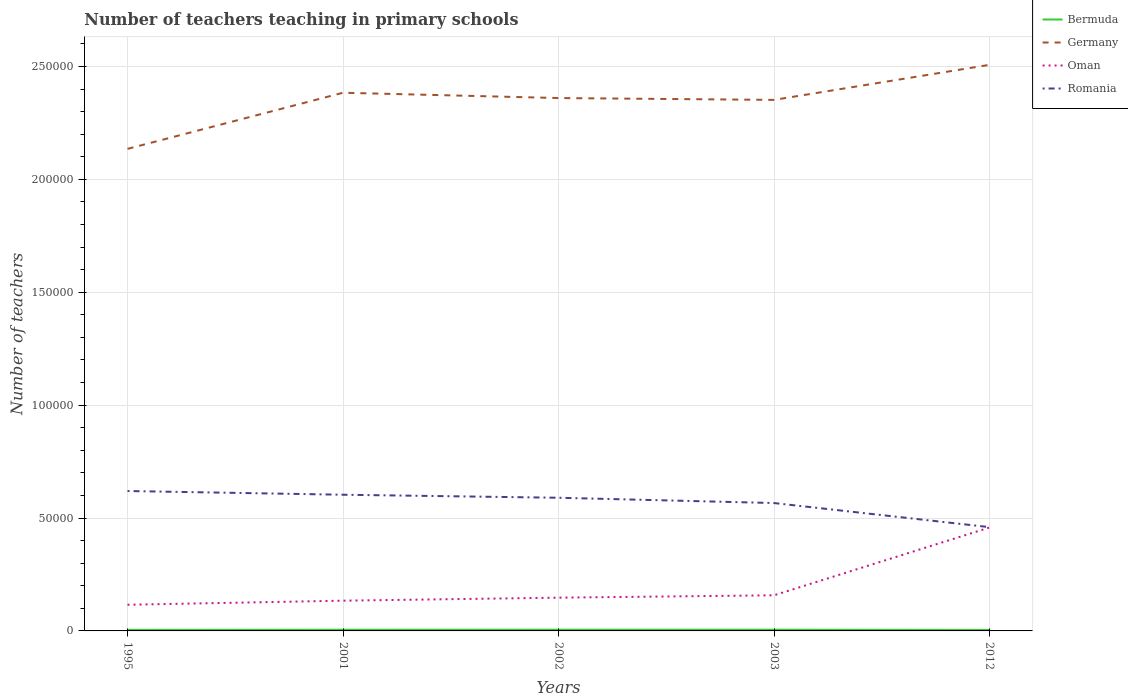How many different coloured lines are there?
Keep it short and to the point. 4. Does the line corresponding to Bermuda intersect with the line corresponding to Oman?
Provide a succinct answer. No. Across all years, what is the maximum number of teachers teaching in primary schools in Romania?
Offer a very short reply. 4.60e+04. In which year was the number of teachers teaching in primary schools in Romania maximum?
Your answer should be very brief. 2012. What is the total number of teachers teaching in primary schools in Germany in the graph?
Give a very brief answer. -2.49e+04. What is the difference between the highest and the second highest number of teachers teaching in primary schools in Germany?
Your response must be concise. 3.72e+04. What is the difference between the highest and the lowest number of teachers teaching in primary schools in Bermuda?
Your answer should be very brief. 3. Is the number of teachers teaching in primary schools in Oman strictly greater than the number of teachers teaching in primary schools in Romania over the years?
Ensure brevity in your answer.  Yes. What is the difference between two consecutive major ticks on the Y-axis?
Your response must be concise. 5.00e+04. Does the graph contain any zero values?
Ensure brevity in your answer.  No. Where does the legend appear in the graph?
Give a very brief answer. Top right. How many legend labels are there?
Your answer should be compact. 4. How are the legend labels stacked?
Offer a terse response. Vertical. What is the title of the graph?
Provide a short and direct response. Number of teachers teaching in primary schools. Does "Estonia" appear as one of the legend labels in the graph?
Make the answer very short. No. What is the label or title of the X-axis?
Provide a short and direct response. Years. What is the label or title of the Y-axis?
Offer a very short reply. Number of teachers. What is the Number of teachers in Bermuda in 1995?
Provide a short and direct response. 463. What is the Number of teachers in Germany in 1995?
Provide a succinct answer. 2.13e+05. What is the Number of teachers of Oman in 1995?
Offer a terse response. 1.16e+04. What is the Number of teachers of Romania in 1995?
Provide a short and direct response. 6.20e+04. What is the Number of teachers of Bermuda in 2001?
Provide a succinct answer. 536. What is the Number of teachers of Germany in 2001?
Your answer should be compact. 2.38e+05. What is the Number of teachers of Oman in 2001?
Ensure brevity in your answer.  1.34e+04. What is the Number of teachers of Romania in 2001?
Your answer should be compact. 6.03e+04. What is the Number of teachers in Bermuda in 2002?
Your answer should be very brief. 548. What is the Number of teachers in Germany in 2002?
Keep it short and to the point. 2.36e+05. What is the Number of teachers in Oman in 2002?
Provide a succinct answer. 1.47e+04. What is the Number of teachers in Romania in 2002?
Give a very brief answer. 5.90e+04. What is the Number of teachers in Bermuda in 2003?
Provide a short and direct response. 548. What is the Number of teachers of Germany in 2003?
Your response must be concise. 2.35e+05. What is the Number of teachers in Oman in 2003?
Offer a very short reply. 1.58e+04. What is the Number of teachers in Romania in 2003?
Your answer should be very brief. 5.66e+04. What is the Number of teachers of Bermuda in 2012?
Make the answer very short. 429. What is the Number of teachers of Germany in 2012?
Keep it short and to the point. 2.51e+05. What is the Number of teachers of Oman in 2012?
Provide a short and direct response. 4.58e+04. What is the Number of teachers of Romania in 2012?
Your answer should be very brief. 4.60e+04. Across all years, what is the maximum Number of teachers of Bermuda?
Make the answer very short. 548. Across all years, what is the maximum Number of teachers of Germany?
Offer a terse response. 2.51e+05. Across all years, what is the maximum Number of teachers of Oman?
Your answer should be compact. 4.58e+04. Across all years, what is the maximum Number of teachers in Romania?
Offer a terse response. 6.20e+04. Across all years, what is the minimum Number of teachers in Bermuda?
Offer a very short reply. 429. Across all years, what is the minimum Number of teachers in Germany?
Offer a terse response. 2.13e+05. Across all years, what is the minimum Number of teachers of Oman?
Make the answer very short. 1.16e+04. Across all years, what is the minimum Number of teachers in Romania?
Keep it short and to the point. 4.60e+04. What is the total Number of teachers in Bermuda in the graph?
Keep it short and to the point. 2524. What is the total Number of teachers in Germany in the graph?
Give a very brief answer. 1.17e+06. What is the total Number of teachers in Oman in the graph?
Keep it short and to the point. 1.01e+05. What is the total Number of teachers in Romania in the graph?
Offer a terse response. 2.84e+05. What is the difference between the Number of teachers of Bermuda in 1995 and that in 2001?
Ensure brevity in your answer.  -73. What is the difference between the Number of teachers of Germany in 1995 and that in 2001?
Keep it short and to the point. -2.49e+04. What is the difference between the Number of teachers of Oman in 1995 and that in 2001?
Ensure brevity in your answer.  -1808. What is the difference between the Number of teachers of Romania in 1995 and that in 2001?
Offer a very short reply. 1648. What is the difference between the Number of teachers of Bermuda in 1995 and that in 2002?
Provide a short and direct response. -85. What is the difference between the Number of teachers in Germany in 1995 and that in 2002?
Your response must be concise. -2.25e+04. What is the difference between the Number of teachers in Oman in 1995 and that in 2002?
Make the answer very short. -3142. What is the difference between the Number of teachers of Romania in 1995 and that in 2002?
Offer a very short reply. 2982. What is the difference between the Number of teachers in Bermuda in 1995 and that in 2003?
Give a very brief answer. -85. What is the difference between the Number of teachers of Germany in 1995 and that in 2003?
Your answer should be very brief. -2.17e+04. What is the difference between the Number of teachers in Oman in 1995 and that in 2003?
Give a very brief answer. -4189. What is the difference between the Number of teachers in Romania in 1995 and that in 2003?
Make the answer very short. 5325. What is the difference between the Number of teachers in Bermuda in 1995 and that in 2012?
Provide a short and direct response. 34. What is the difference between the Number of teachers in Germany in 1995 and that in 2012?
Provide a short and direct response. -3.72e+04. What is the difference between the Number of teachers of Oman in 1995 and that in 2012?
Provide a short and direct response. -3.42e+04. What is the difference between the Number of teachers of Romania in 1995 and that in 2012?
Give a very brief answer. 1.60e+04. What is the difference between the Number of teachers of Germany in 2001 and that in 2002?
Your answer should be compact. 2352. What is the difference between the Number of teachers of Oman in 2001 and that in 2002?
Your answer should be compact. -1334. What is the difference between the Number of teachers of Romania in 2001 and that in 2002?
Give a very brief answer. 1334. What is the difference between the Number of teachers in Bermuda in 2001 and that in 2003?
Offer a terse response. -12. What is the difference between the Number of teachers in Germany in 2001 and that in 2003?
Your answer should be compact. 3166. What is the difference between the Number of teachers in Oman in 2001 and that in 2003?
Keep it short and to the point. -2381. What is the difference between the Number of teachers in Romania in 2001 and that in 2003?
Ensure brevity in your answer.  3677. What is the difference between the Number of teachers of Bermuda in 2001 and that in 2012?
Provide a succinct answer. 107. What is the difference between the Number of teachers of Germany in 2001 and that in 2012?
Offer a terse response. -1.24e+04. What is the difference between the Number of teachers in Oman in 2001 and that in 2012?
Your answer should be very brief. -3.24e+04. What is the difference between the Number of teachers in Romania in 2001 and that in 2012?
Provide a succinct answer. 1.44e+04. What is the difference between the Number of teachers of Bermuda in 2002 and that in 2003?
Make the answer very short. 0. What is the difference between the Number of teachers of Germany in 2002 and that in 2003?
Make the answer very short. 814. What is the difference between the Number of teachers of Oman in 2002 and that in 2003?
Offer a terse response. -1047. What is the difference between the Number of teachers of Romania in 2002 and that in 2003?
Ensure brevity in your answer.  2343. What is the difference between the Number of teachers in Bermuda in 2002 and that in 2012?
Make the answer very short. 119. What is the difference between the Number of teachers in Germany in 2002 and that in 2012?
Keep it short and to the point. -1.47e+04. What is the difference between the Number of teachers of Oman in 2002 and that in 2012?
Your response must be concise. -3.11e+04. What is the difference between the Number of teachers in Romania in 2002 and that in 2012?
Your answer should be compact. 1.30e+04. What is the difference between the Number of teachers of Bermuda in 2003 and that in 2012?
Give a very brief answer. 119. What is the difference between the Number of teachers of Germany in 2003 and that in 2012?
Provide a succinct answer. -1.55e+04. What is the difference between the Number of teachers of Oman in 2003 and that in 2012?
Your response must be concise. -3.00e+04. What is the difference between the Number of teachers in Romania in 2003 and that in 2012?
Provide a short and direct response. 1.07e+04. What is the difference between the Number of teachers of Bermuda in 1995 and the Number of teachers of Germany in 2001?
Your answer should be compact. -2.38e+05. What is the difference between the Number of teachers of Bermuda in 1995 and the Number of teachers of Oman in 2001?
Provide a short and direct response. -1.29e+04. What is the difference between the Number of teachers in Bermuda in 1995 and the Number of teachers in Romania in 2001?
Provide a succinct answer. -5.98e+04. What is the difference between the Number of teachers of Germany in 1995 and the Number of teachers of Oman in 2001?
Your answer should be compact. 2.00e+05. What is the difference between the Number of teachers of Germany in 1995 and the Number of teachers of Romania in 2001?
Give a very brief answer. 1.53e+05. What is the difference between the Number of teachers of Oman in 1995 and the Number of teachers of Romania in 2001?
Make the answer very short. -4.87e+04. What is the difference between the Number of teachers in Bermuda in 1995 and the Number of teachers in Germany in 2002?
Keep it short and to the point. -2.36e+05. What is the difference between the Number of teachers of Bermuda in 1995 and the Number of teachers of Oman in 2002?
Ensure brevity in your answer.  -1.43e+04. What is the difference between the Number of teachers in Bermuda in 1995 and the Number of teachers in Romania in 2002?
Offer a terse response. -5.85e+04. What is the difference between the Number of teachers of Germany in 1995 and the Number of teachers of Oman in 2002?
Your answer should be compact. 1.99e+05. What is the difference between the Number of teachers in Germany in 1995 and the Number of teachers in Romania in 2002?
Give a very brief answer. 1.55e+05. What is the difference between the Number of teachers in Oman in 1995 and the Number of teachers in Romania in 2002?
Offer a terse response. -4.74e+04. What is the difference between the Number of teachers in Bermuda in 1995 and the Number of teachers in Germany in 2003?
Your answer should be very brief. -2.35e+05. What is the difference between the Number of teachers of Bermuda in 1995 and the Number of teachers of Oman in 2003?
Your answer should be compact. -1.53e+04. What is the difference between the Number of teachers of Bermuda in 1995 and the Number of teachers of Romania in 2003?
Provide a succinct answer. -5.62e+04. What is the difference between the Number of teachers of Germany in 1995 and the Number of teachers of Oman in 2003?
Ensure brevity in your answer.  1.98e+05. What is the difference between the Number of teachers in Germany in 1995 and the Number of teachers in Romania in 2003?
Offer a very short reply. 1.57e+05. What is the difference between the Number of teachers of Oman in 1995 and the Number of teachers of Romania in 2003?
Offer a terse response. -4.50e+04. What is the difference between the Number of teachers in Bermuda in 1995 and the Number of teachers in Germany in 2012?
Make the answer very short. -2.50e+05. What is the difference between the Number of teachers in Bermuda in 1995 and the Number of teachers in Oman in 2012?
Ensure brevity in your answer.  -4.53e+04. What is the difference between the Number of teachers in Bermuda in 1995 and the Number of teachers in Romania in 2012?
Offer a very short reply. -4.55e+04. What is the difference between the Number of teachers of Germany in 1995 and the Number of teachers of Oman in 2012?
Keep it short and to the point. 1.68e+05. What is the difference between the Number of teachers of Germany in 1995 and the Number of teachers of Romania in 2012?
Your answer should be very brief. 1.68e+05. What is the difference between the Number of teachers of Oman in 1995 and the Number of teachers of Romania in 2012?
Ensure brevity in your answer.  -3.44e+04. What is the difference between the Number of teachers in Bermuda in 2001 and the Number of teachers in Germany in 2002?
Provide a short and direct response. -2.35e+05. What is the difference between the Number of teachers of Bermuda in 2001 and the Number of teachers of Oman in 2002?
Your answer should be compact. -1.42e+04. What is the difference between the Number of teachers of Bermuda in 2001 and the Number of teachers of Romania in 2002?
Keep it short and to the point. -5.84e+04. What is the difference between the Number of teachers of Germany in 2001 and the Number of teachers of Oman in 2002?
Keep it short and to the point. 2.24e+05. What is the difference between the Number of teachers of Germany in 2001 and the Number of teachers of Romania in 2002?
Your response must be concise. 1.79e+05. What is the difference between the Number of teachers of Oman in 2001 and the Number of teachers of Romania in 2002?
Keep it short and to the point. -4.56e+04. What is the difference between the Number of teachers of Bermuda in 2001 and the Number of teachers of Germany in 2003?
Your answer should be very brief. -2.35e+05. What is the difference between the Number of teachers of Bermuda in 2001 and the Number of teachers of Oman in 2003?
Your answer should be compact. -1.52e+04. What is the difference between the Number of teachers of Bermuda in 2001 and the Number of teachers of Romania in 2003?
Your answer should be very brief. -5.61e+04. What is the difference between the Number of teachers of Germany in 2001 and the Number of teachers of Oman in 2003?
Your response must be concise. 2.23e+05. What is the difference between the Number of teachers in Germany in 2001 and the Number of teachers in Romania in 2003?
Provide a succinct answer. 1.82e+05. What is the difference between the Number of teachers in Oman in 2001 and the Number of teachers in Romania in 2003?
Your answer should be compact. -4.32e+04. What is the difference between the Number of teachers in Bermuda in 2001 and the Number of teachers in Germany in 2012?
Make the answer very short. -2.50e+05. What is the difference between the Number of teachers in Bermuda in 2001 and the Number of teachers in Oman in 2012?
Offer a very short reply. -4.53e+04. What is the difference between the Number of teachers in Bermuda in 2001 and the Number of teachers in Romania in 2012?
Your answer should be very brief. -4.54e+04. What is the difference between the Number of teachers in Germany in 2001 and the Number of teachers in Oman in 2012?
Make the answer very short. 1.93e+05. What is the difference between the Number of teachers of Germany in 2001 and the Number of teachers of Romania in 2012?
Ensure brevity in your answer.  1.92e+05. What is the difference between the Number of teachers of Oman in 2001 and the Number of teachers of Romania in 2012?
Your answer should be compact. -3.26e+04. What is the difference between the Number of teachers of Bermuda in 2002 and the Number of teachers of Germany in 2003?
Offer a very short reply. -2.35e+05. What is the difference between the Number of teachers of Bermuda in 2002 and the Number of teachers of Oman in 2003?
Keep it short and to the point. -1.52e+04. What is the difference between the Number of teachers of Bermuda in 2002 and the Number of teachers of Romania in 2003?
Provide a succinct answer. -5.61e+04. What is the difference between the Number of teachers in Germany in 2002 and the Number of teachers in Oman in 2003?
Offer a very short reply. 2.20e+05. What is the difference between the Number of teachers in Germany in 2002 and the Number of teachers in Romania in 2003?
Make the answer very short. 1.79e+05. What is the difference between the Number of teachers of Oman in 2002 and the Number of teachers of Romania in 2003?
Ensure brevity in your answer.  -4.19e+04. What is the difference between the Number of teachers of Bermuda in 2002 and the Number of teachers of Germany in 2012?
Keep it short and to the point. -2.50e+05. What is the difference between the Number of teachers in Bermuda in 2002 and the Number of teachers in Oman in 2012?
Your answer should be very brief. -4.52e+04. What is the difference between the Number of teachers of Bermuda in 2002 and the Number of teachers of Romania in 2012?
Offer a very short reply. -4.54e+04. What is the difference between the Number of teachers in Germany in 2002 and the Number of teachers in Oman in 2012?
Keep it short and to the point. 1.90e+05. What is the difference between the Number of teachers in Germany in 2002 and the Number of teachers in Romania in 2012?
Provide a succinct answer. 1.90e+05. What is the difference between the Number of teachers in Oman in 2002 and the Number of teachers in Romania in 2012?
Provide a succinct answer. -3.12e+04. What is the difference between the Number of teachers in Bermuda in 2003 and the Number of teachers in Germany in 2012?
Provide a succinct answer. -2.50e+05. What is the difference between the Number of teachers of Bermuda in 2003 and the Number of teachers of Oman in 2012?
Keep it short and to the point. -4.52e+04. What is the difference between the Number of teachers of Bermuda in 2003 and the Number of teachers of Romania in 2012?
Provide a succinct answer. -4.54e+04. What is the difference between the Number of teachers of Germany in 2003 and the Number of teachers of Oman in 2012?
Provide a succinct answer. 1.89e+05. What is the difference between the Number of teachers of Germany in 2003 and the Number of teachers of Romania in 2012?
Your answer should be compact. 1.89e+05. What is the difference between the Number of teachers of Oman in 2003 and the Number of teachers of Romania in 2012?
Give a very brief answer. -3.02e+04. What is the average Number of teachers in Bermuda per year?
Ensure brevity in your answer.  504.8. What is the average Number of teachers in Germany per year?
Offer a very short reply. 2.35e+05. What is the average Number of teachers of Oman per year?
Offer a very short reply. 2.03e+04. What is the average Number of teachers in Romania per year?
Provide a succinct answer. 5.68e+04. In the year 1995, what is the difference between the Number of teachers of Bermuda and Number of teachers of Germany?
Provide a succinct answer. -2.13e+05. In the year 1995, what is the difference between the Number of teachers in Bermuda and Number of teachers in Oman?
Ensure brevity in your answer.  -1.11e+04. In the year 1995, what is the difference between the Number of teachers of Bermuda and Number of teachers of Romania?
Ensure brevity in your answer.  -6.15e+04. In the year 1995, what is the difference between the Number of teachers in Germany and Number of teachers in Oman?
Offer a terse response. 2.02e+05. In the year 1995, what is the difference between the Number of teachers in Germany and Number of teachers in Romania?
Keep it short and to the point. 1.52e+05. In the year 1995, what is the difference between the Number of teachers in Oman and Number of teachers in Romania?
Provide a succinct answer. -5.04e+04. In the year 2001, what is the difference between the Number of teachers in Bermuda and Number of teachers in Germany?
Offer a terse response. -2.38e+05. In the year 2001, what is the difference between the Number of teachers in Bermuda and Number of teachers in Oman?
Offer a very short reply. -1.29e+04. In the year 2001, what is the difference between the Number of teachers of Bermuda and Number of teachers of Romania?
Give a very brief answer. -5.98e+04. In the year 2001, what is the difference between the Number of teachers of Germany and Number of teachers of Oman?
Ensure brevity in your answer.  2.25e+05. In the year 2001, what is the difference between the Number of teachers in Germany and Number of teachers in Romania?
Keep it short and to the point. 1.78e+05. In the year 2001, what is the difference between the Number of teachers of Oman and Number of teachers of Romania?
Offer a terse response. -4.69e+04. In the year 2002, what is the difference between the Number of teachers in Bermuda and Number of teachers in Germany?
Provide a succinct answer. -2.35e+05. In the year 2002, what is the difference between the Number of teachers in Bermuda and Number of teachers in Oman?
Provide a short and direct response. -1.42e+04. In the year 2002, what is the difference between the Number of teachers of Bermuda and Number of teachers of Romania?
Make the answer very short. -5.84e+04. In the year 2002, what is the difference between the Number of teachers in Germany and Number of teachers in Oman?
Make the answer very short. 2.21e+05. In the year 2002, what is the difference between the Number of teachers of Germany and Number of teachers of Romania?
Give a very brief answer. 1.77e+05. In the year 2002, what is the difference between the Number of teachers of Oman and Number of teachers of Romania?
Your answer should be very brief. -4.42e+04. In the year 2003, what is the difference between the Number of teachers of Bermuda and Number of teachers of Germany?
Your answer should be compact. -2.35e+05. In the year 2003, what is the difference between the Number of teachers of Bermuda and Number of teachers of Oman?
Provide a short and direct response. -1.52e+04. In the year 2003, what is the difference between the Number of teachers in Bermuda and Number of teachers in Romania?
Make the answer very short. -5.61e+04. In the year 2003, what is the difference between the Number of teachers in Germany and Number of teachers in Oman?
Offer a very short reply. 2.19e+05. In the year 2003, what is the difference between the Number of teachers of Germany and Number of teachers of Romania?
Provide a succinct answer. 1.79e+05. In the year 2003, what is the difference between the Number of teachers in Oman and Number of teachers in Romania?
Keep it short and to the point. -4.09e+04. In the year 2012, what is the difference between the Number of teachers of Bermuda and Number of teachers of Germany?
Offer a terse response. -2.50e+05. In the year 2012, what is the difference between the Number of teachers in Bermuda and Number of teachers in Oman?
Give a very brief answer. -4.54e+04. In the year 2012, what is the difference between the Number of teachers of Bermuda and Number of teachers of Romania?
Give a very brief answer. -4.55e+04. In the year 2012, what is the difference between the Number of teachers of Germany and Number of teachers of Oman?
Your answer should be compact. 2.05e+05. In the year 2012, what is the difference between the Number of teachers of Germany and Number of teachers of Romania?
Your answer should be compact. 2.05e+05. In the year 2012, what is the difference between the Number of teachers in Oman and Number of teachers in Romania?
Make the answer very short. -167. What is the ratio of the Number of teachers in Bermuda in 1995 to that in 2001?
Provide a short and direct response. 0.86. What is the ratio of the Number of teachers in Germany in 1995 to that in 2001?
Your answer should be compact. 0.9. What is the ratio of the Number of teachers of Oman in 1995 to that in 2001?
Ensure brevity in your answer.  0.86. What is the ratio of the Number of teachers in Romania in 1995 to that in 2001?
Provide a short and direct response. 1.03. What is the ratio of the Number of teachers of Bermuda in 1995 to that in 2002?
Give a very brief answer. 0.84. What is the ratio of the Number of teachers in Germany in 1995 to that in 2002?
Your response must be concise. 0.9. What is the ratio of the Number of teachers of Oman in 1995 to that in 2002?
Keep it short and to the point. 0.79. What is the ratio of the Number of teachers in Romania in 1995 to that in 2002?
Offer a terse response. 1.05. What is the ratio of the Number of teachers of Bermuda in 1995 to that in 2003?
Provide a succinct answer. 0.84. What is the ratio of the Number of teachers in Germany in 1995 to that in 2003?
Offer a terse response. 0.91. What is the ratio of the Number of teachers of Oman in 1995 to that in 2003?
Keep it short and to the point. 0.73. What is the ratio of the Number of teachers of Romania in 1995 to that in 2003?
Make the answer very short. 1.09. What is the ratio of the Number of teachers of Bermuda in 1995 to that in 2012?
Provide a short and direct response. 1.08. What is the ratio of the Number of teachers of Germany in 1995 to that in 2012?
Give a very brief answer. 0.85. What is the ratio of the Number of teachers in Oman in 1995 to that in 2012?
Offer a very short reply. 0.25. What is the ratio of the Number of teachers in Romania in 1995 to that in 2012?
Ensure brevity in your answer.  1.35. What is the ratio of the Number of teachers of Bermuda in 2001 to that in 2002?
Give a very brief answer. 0.98. What is the ratio of the Number of teachers in Germany in 2001 to that in 2002?
Your answer should be compact. 1.01. What is the ratio of the Number of teachers in Oman in 2001 to that in 2002?
Offer a terse response. 0.91. What is the ratio of the Number of teachers in Romania in 2001 to that in 2002?
Ensure brevity in your answer.  1.02. What is the ratio of the Number of teachers in Bermuda in 2001 to that in 2003?
Offer a very short reply. 0.98. What is the ratio of the Number of teachers of Germany in 2001 to that in 2003?
Ensure brevity in your answer.  1.01. What is the ratio of the Number of teachers of Oman in 2001 to that in 2003?
Your answer should be very brief. 0.85. What is the ratio of the Number of teachers of Romania in 2001 to that in 2003?
Your answer should be very brief. 1.06. What is the ratio of the Number of teachers in Bermuda in 2001 to that in 2012?
Ensure brevity in your answer.  1.25. What is the ratio of the Number of teachers of Germany in 2001 to that in 2012?
Provide a short and direct response. 0.95. What is the ratio of the Number of teachers in Oman in 2001 to that in 2012?
Keep it short and to the point. 0.29. What is the ratio of the Number of teachers of Romania in 2001 to that in 2012?
Your response must be concise. 1.31. What is the ratio of the Number of teachers in Oman in 2002 to that in 2003?
Give a very brief answer. 0.93. What is the ratio of the Number of teachers of Romania in 2002 to that in 2003?
Offer a very short reply. 1.04. What is the ratio of the Number of teachers in Bermuda in 2002 to that in 2012?
Your answer should be very brief. 1.28. What is the ratio of the Number of teachers of Germany in 2002 to that in 2012?
Your answer should be compact. 0.94. What is the ratio of the Number of teachers of Oman in 2002 to that in 2012?
Offer a terse response. 0.32. What is the ratio of the Number of teachers in Romania in 2002 to that in 2012?
Your answer should be very brief. 1.28. What is the ratio of the Number of teachers in Bermuda in 2003 to that in 2012?
Provide a succinct answer. 1.28. What is the ratio of the Number of teachers of Germany in 2003 to that in 2012?
Give a very brief answer. 0.94. What is the ratio of the Number of teachers of Oman in 2003 to that in 2012?
Keep it short and to the point. 0.34. What is the ratio of the Number of teachers in Romania in 2003 to that in 2012?
Offer a terse response. 1.23. What is the difference between the highest and the second highest Number of teachers of Germany?
Your answer should be very brief. 1.24e+04. What is the difference between the highest and the second highest Number of teachers of Oman?
Your response must be concise. 3.00e+04. What is the difference between the highest and the second highest Number of teachers of Romania?
Give a very brief answer. 1648. What is the difference between the highest and the lowest Number of teachers of Bermuda?
Your answer should be compact. 119. What is the difference between the highest and the lowest Number of teachers in Germany?
Your response must be concise. 3.72e+04. What is the difference between the highest and the lowest Number of teachers in Oman?
Give a very brief answer. 3.42e+04. What is the difference between the highest and the lowest Number of teachers in Romania?
Your answer should be compact. 1.60e+04. 